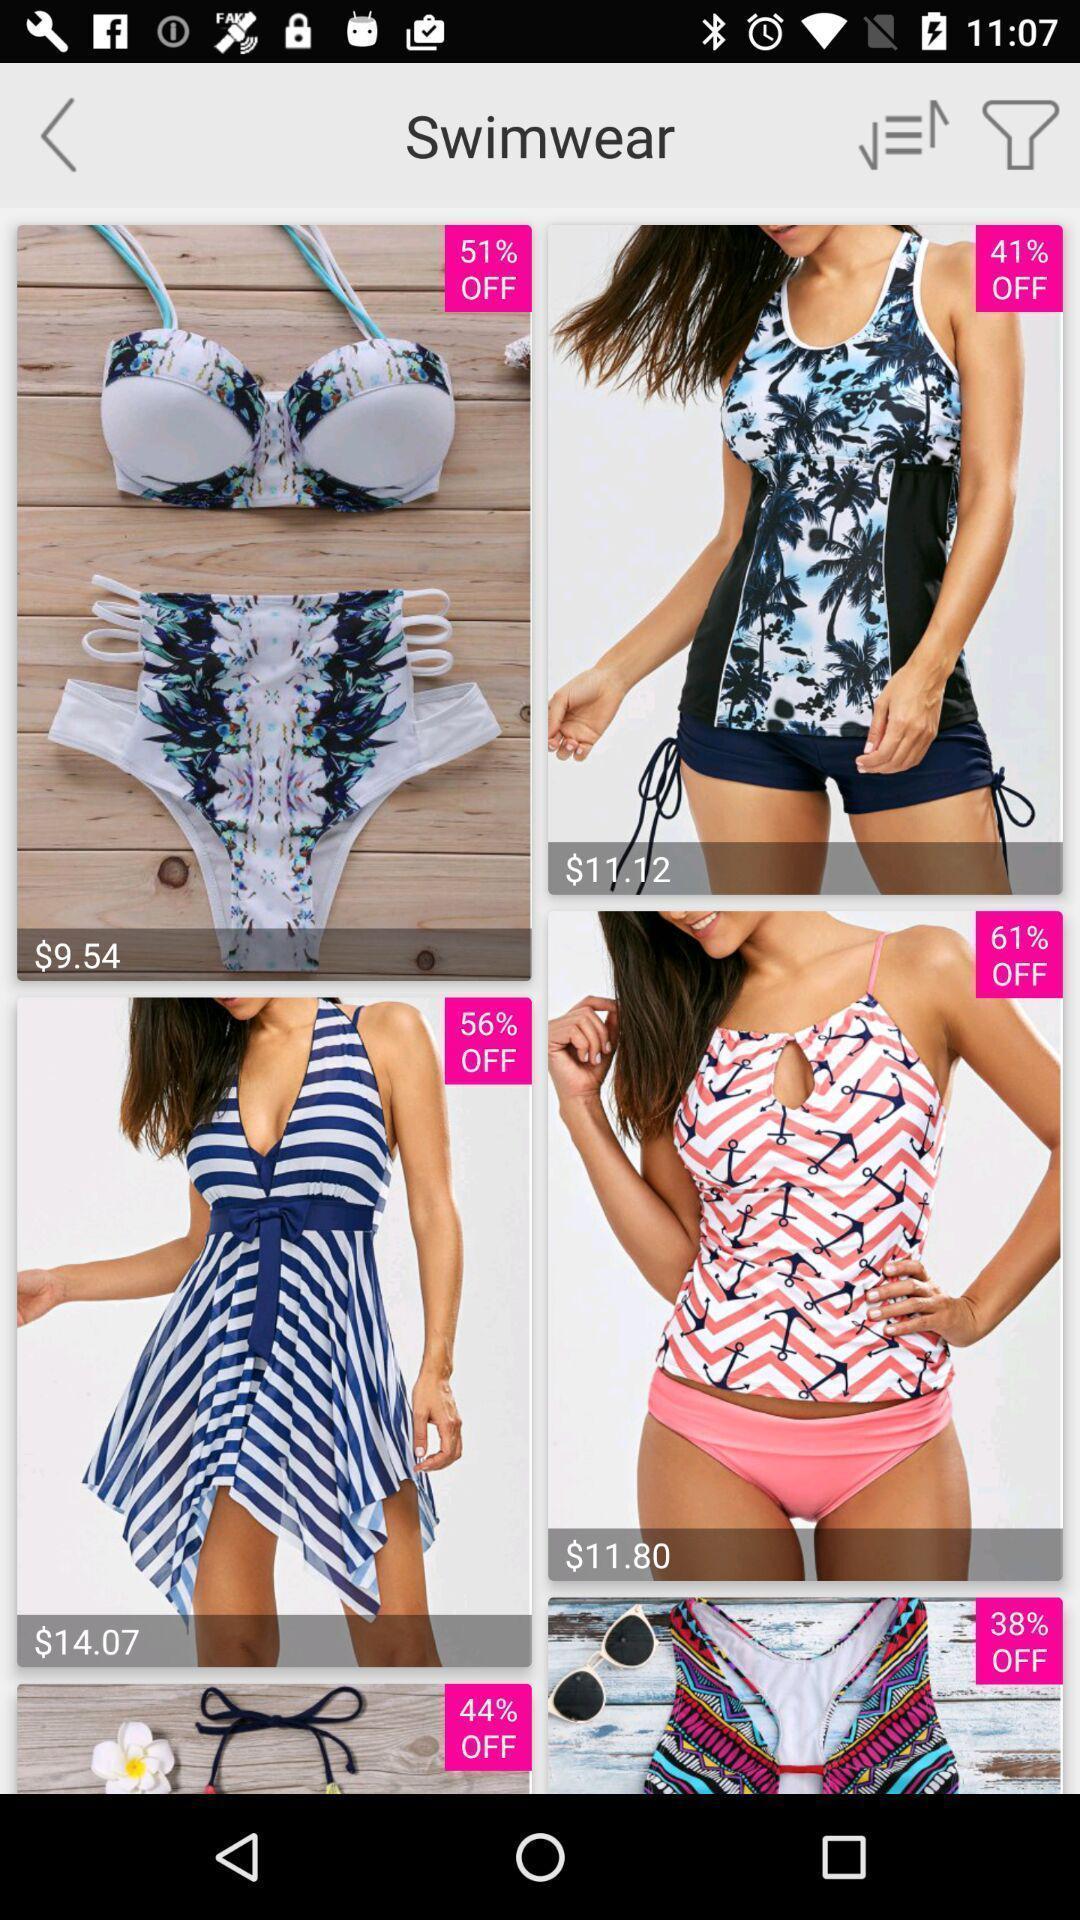Explain the elements present in this screenshot. Various clothing outfit displayed of a online shopping app. 